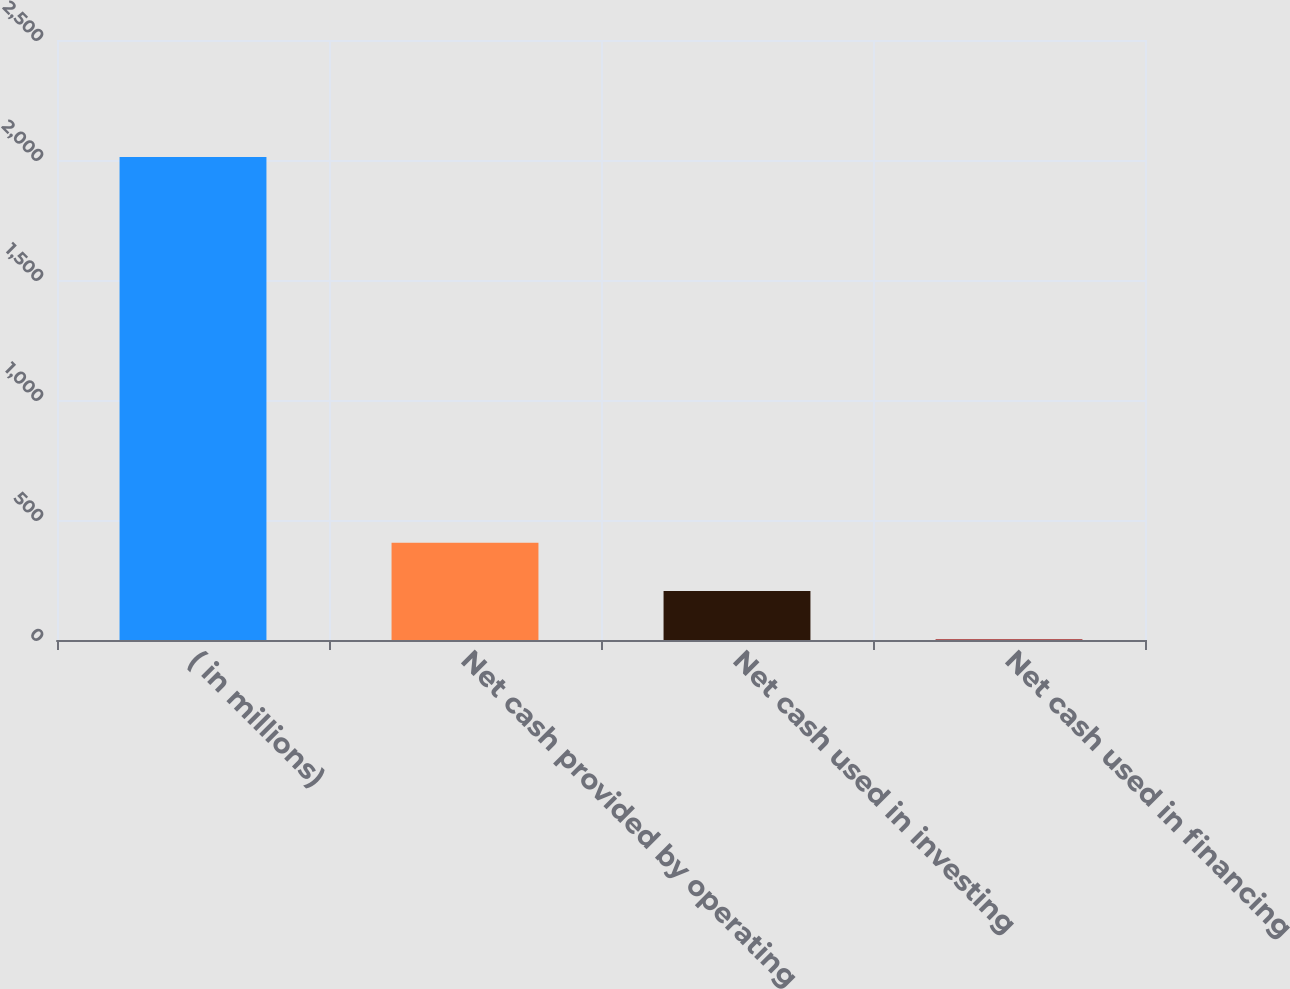<chart> <loc_0><loc_0><loc_500><loc_500><bar_chart><fcel>( in millions)<fcel>Net cash provided by operating<fcel>Net cash used in investing<fcel>Net cash used in financing<nl><fcel>2012<fcel>405.12<fcel>204.26<fcel>3.4<nl></chart> 